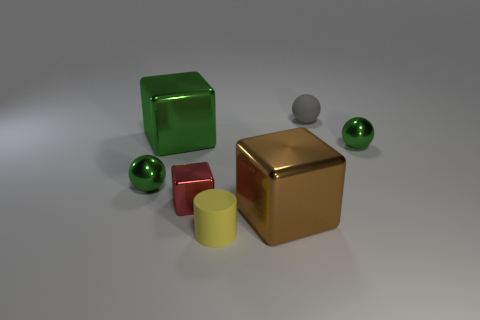Add 2 small green shiny balls. How many objects exist? 9 Subtract all spheres. How many objects are left? 4 Subtract all large brown metal objects. Subtract all yellow matte cylinders. How many objects are left? 5 Add 7 tiny gray matte spheres. How many tiny gray matte spheres are left? 8 Add 5 big green objects. How many big green objects exist? 6 Subtract 0 purple cylinders. How many objects are left? 7 